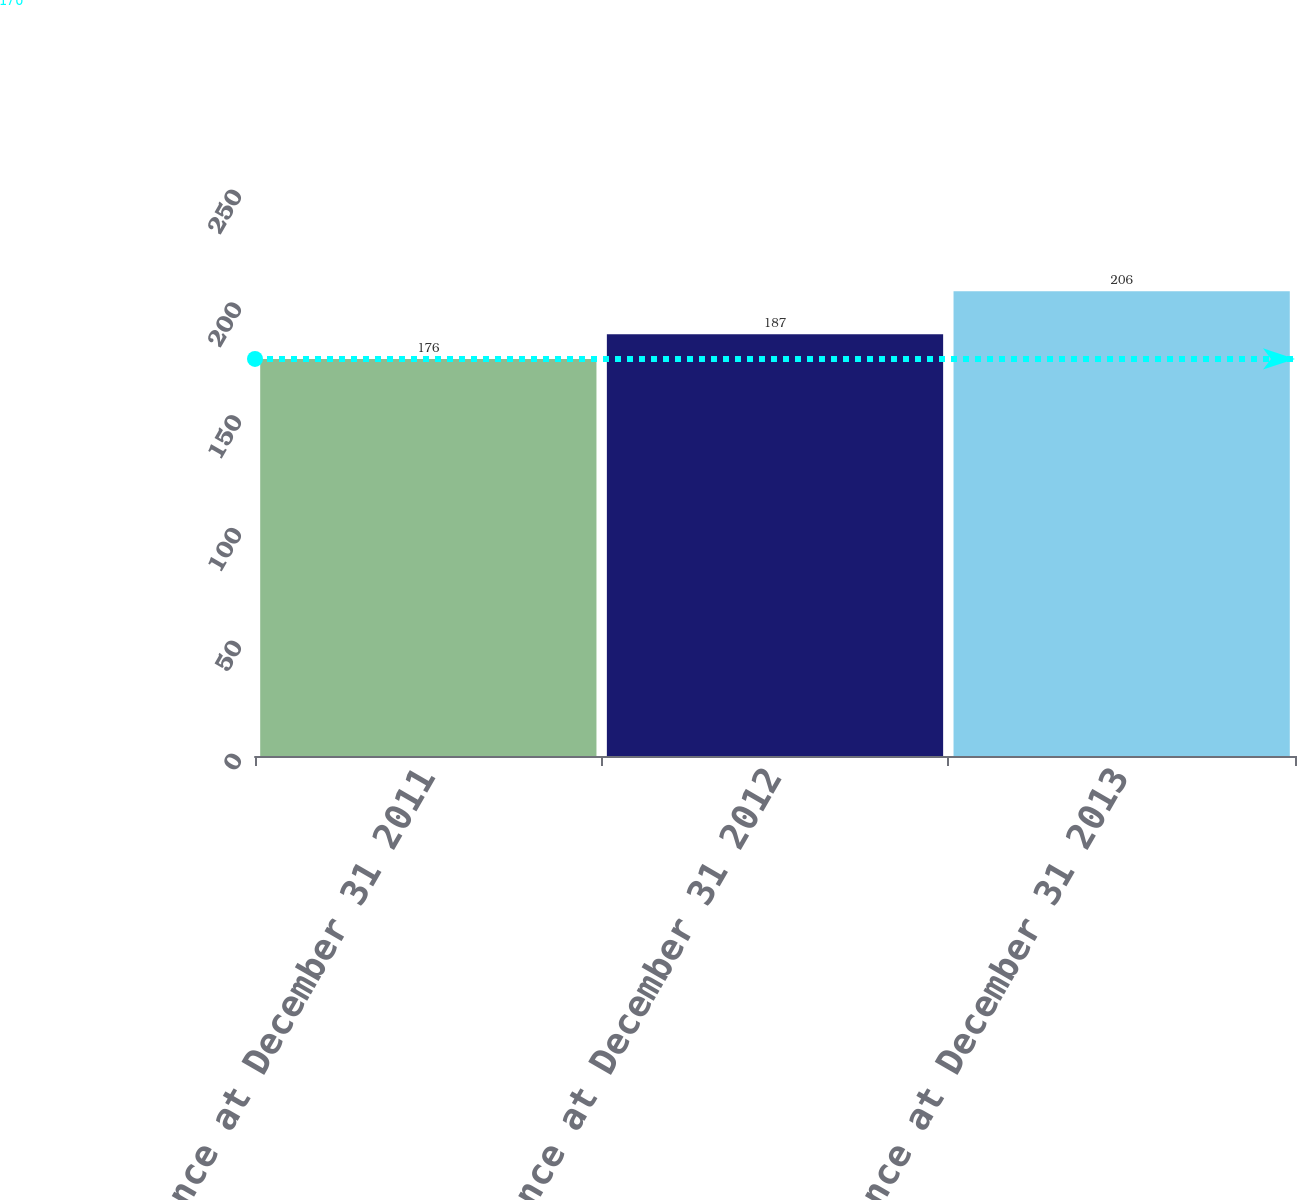Convert chart to OTSL. <chart><loc_0><loc_0><loc_500><loc_500><bar_chart><fcel>Balance at December 31 2011<fcel>Balance at December 31 2012<fcel>Balance at December 31 2013<nl><fcel>176<fcel>187<fcel>206<nl></chart> 